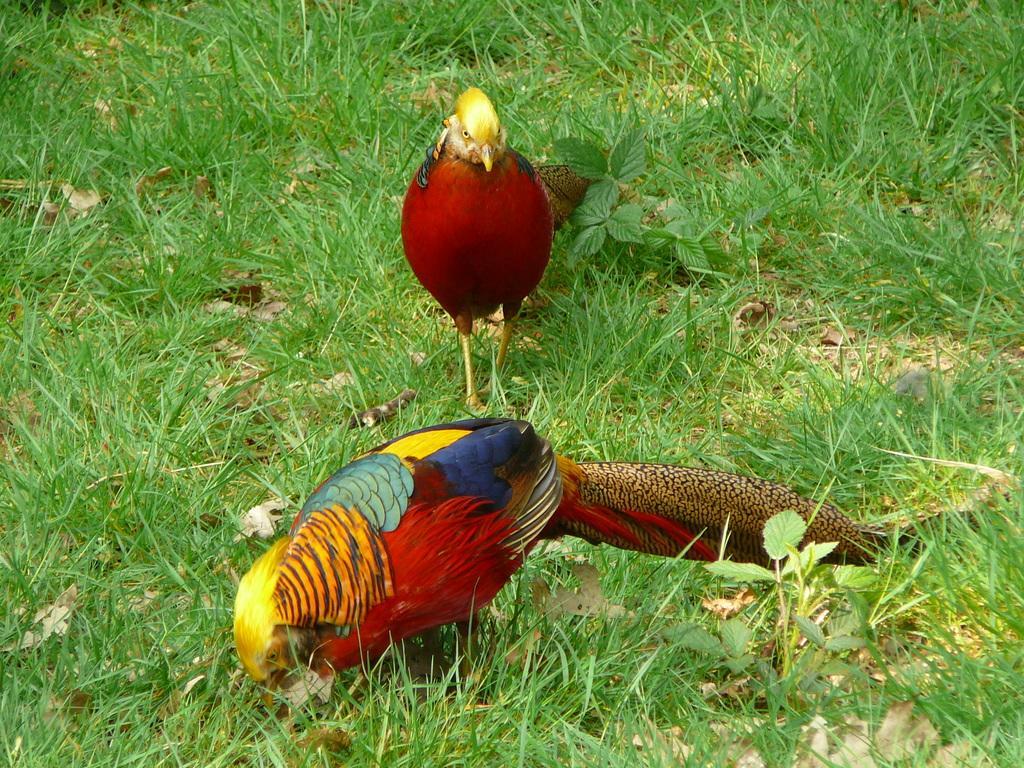Please provide a concise description of this image. In this image we can see birds standing on the ground, grass and shredded leaves. 